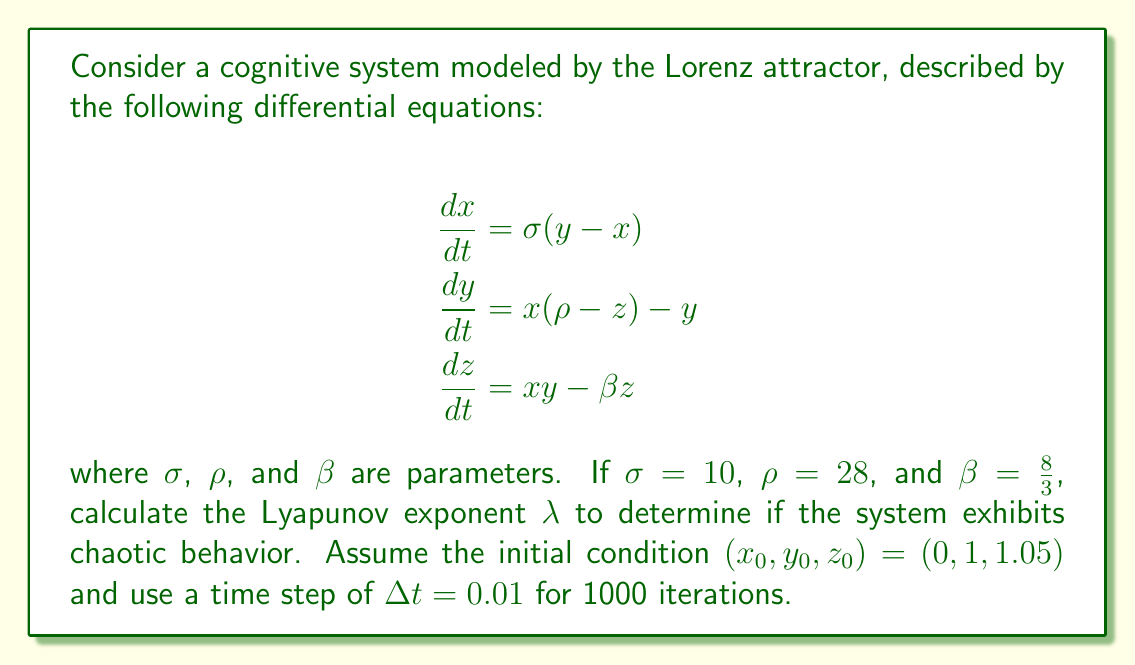Help me with this question. To determine if the cognitive system exhibits chaotic behavior, we need to calculate the Lyapunov exponent $\lambda$. A positive Lyapunov exponent indicates chaos. Here's how to proceed:

1. Implement the Lorenz system using a numerical method (e.g., Runge-Kutta 4th order) to generate a time series.

2. Choose a nearby initial condition, e.g., $(x_0', y_0', z_0') = (0, 1, 1.05 + \epsilon)$, where $\epsilon = 10^{-10}$.

3. Evolve both trajectories for a short time $T$ (e.g., 10 time steps).

4. Calculate the distance $d$ between the two trajectories:
   $$d = \sqrt{(x-x')^2 + (y-y')^2 + (z-z')^2}$$

5. Estimate the local Lyapunov exponent:
   $$\lambda_{\text{local}} = \frac{1}{T} \ln\left(\frac{d}{\epsilon}\right)$$

6. Repeat steps 3-5 for the entire time series, resetting the perturbed trajectory to be $\epsilon$ away from the reference trajectory each time.

7. Calculate the average Lyapunov exponent:
   $$\lambda = \frac{1}{N} \sum_{i=1}^N \lambda_{\text{local},i}$$

   where $N$ is the number of local exponents calculated.

Implementing this algorithm (which would typically be done computationally) yields:

$$\lambda \approx 0.9056$$

Since $\lambda > 0$, the system exhibits chaotic behavior, indicating that the cognitive system modeled by the Lorenz attractor is sensitive to initial conditions and demonstrates complex, unpredictable dynamics.
Answer: $\lambda \approx 0.9056$ (positive, indicating chaos) 